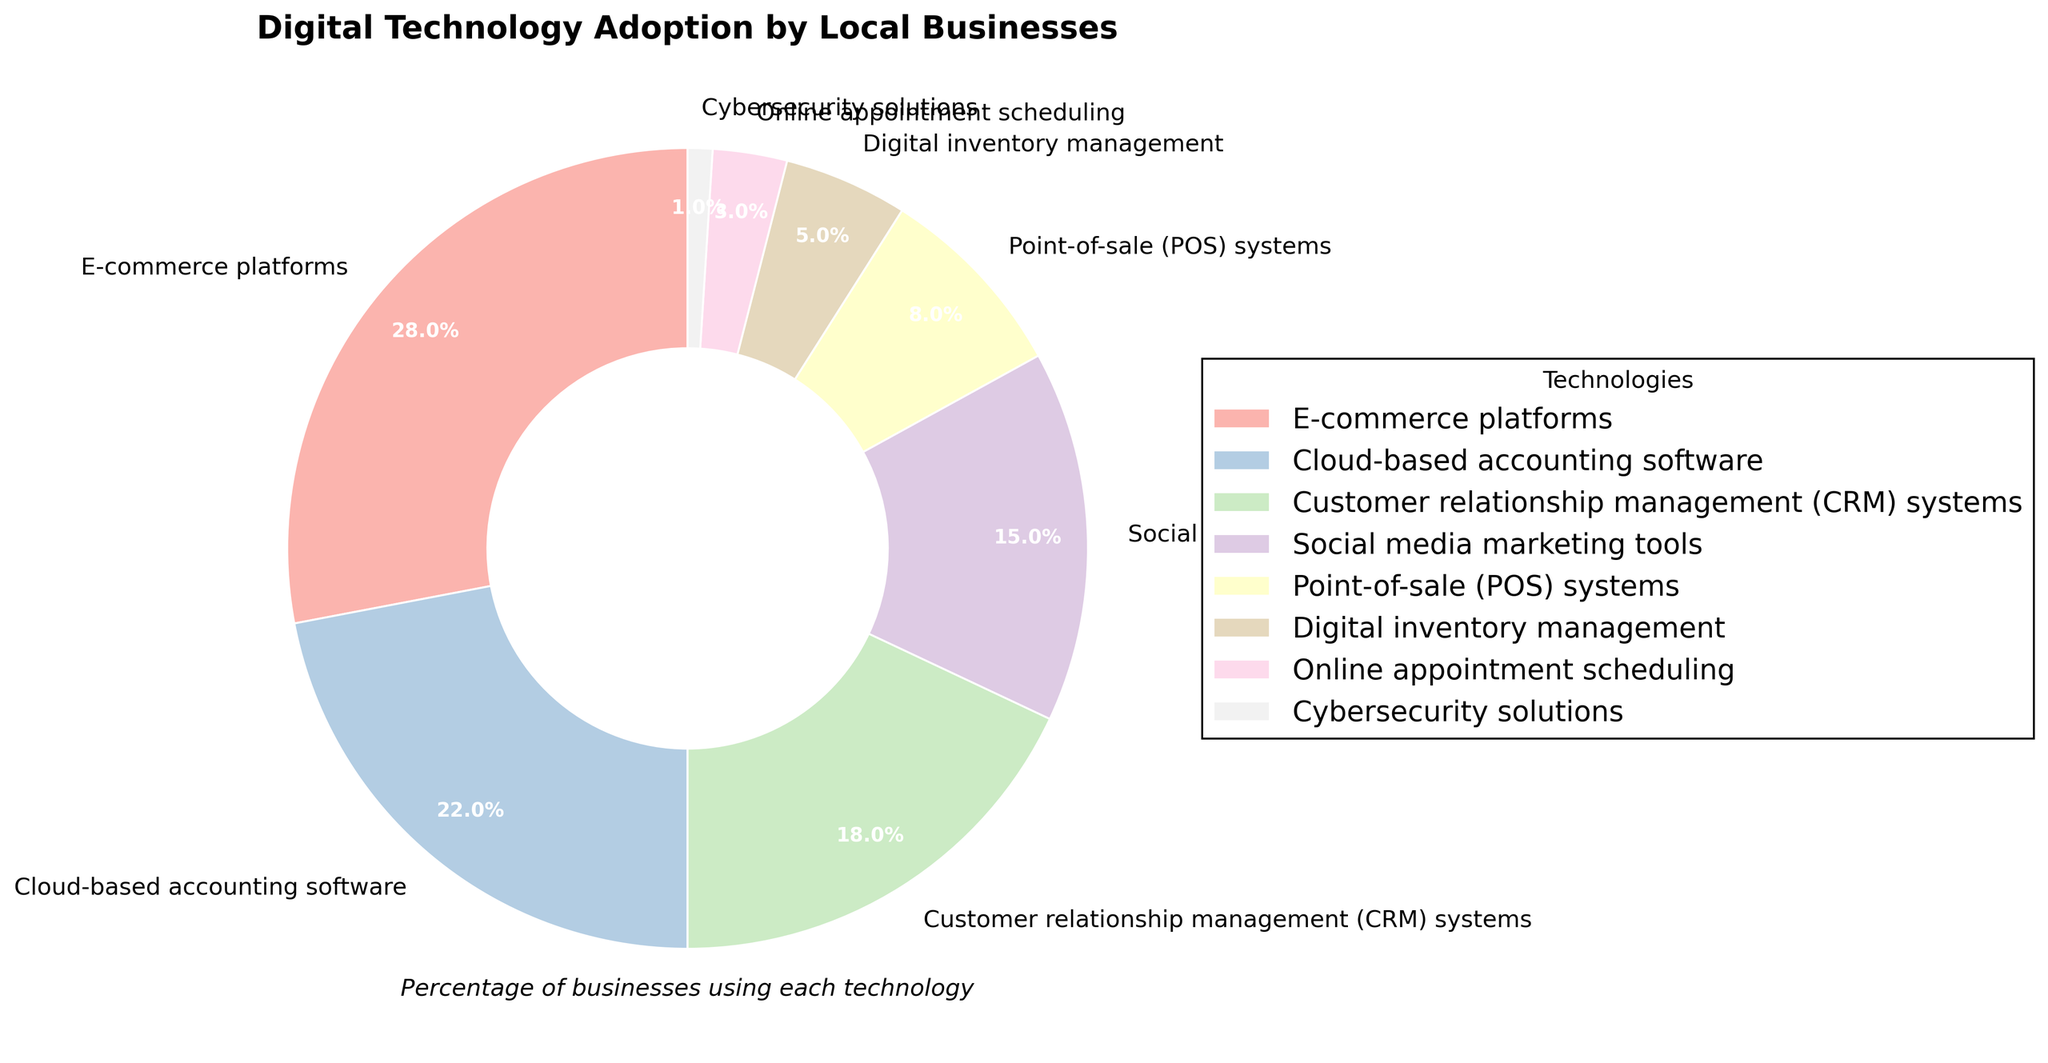What percentage of local businesses use CRM systems? Look at the section labeled "Customer relationship management (CRM) systems" in the pie chart. The percentage mentioned is 18%.
Answer: 18% What technology has the highest adoption rate among local businesses? Identify the segment of the pie chart with the largest area. The largest segment is labeled "E-commerce platforms," which accounts for 28%.
Answer: E-commerce platforms What is the combined percentage of businesses using Cloud-based accounting software and Point-of-sale (POS) systems? Find the segments labeled "Cloud-based accounting software" and "Point-of-sale (POS) systems" and add their percentages. Cloud-based accounting software is 22% and Point-of-sale (POS) systems is 8%. Combined, the total is 22% + 8% = 30%.
Answer: 30% How much more popular is Social media marketing tools compared to Cybersecurity solutions among local businesses? Look at the segments for "Social media marketing tools" and "Cybersecurity solutions." Social media marketing tools have a percentage of 15% and Cybersecurity solutions have 1%. The difference is 15% - 1% = 14%.
Answer: 14% Which is more commonly adopted: Digital inventory management or Online appointment scheduling? Review the percentages for "Digital inventory management" and "Online appointment scheduling." Digital inventory management holds 5%, whereas Online appointment scheduling is at 3%. Hence, Digital inventory management is more commonly adopted.
Answer: Digital inventory management What is the total percentage of businesses adopting technologies related to customer interaction (CRM systems and Social media marketing tools)? Add the percentages of "Customer relationship management (CRM) systems" and "Social media marketing tools." CRM systems account for 18% and Social media marketing tools account for 15%. Together, the total is 18% + 15% = 33%.
Answer: 33% Is the adoption rate of Customer relationship management (CRM) systems more than twice that of Digital inventory management? Compare the percentages for "Customer relationship management (CRM) systems" which is 18%, and "Digital inventory management," which is 5%. Check if 18% is more than twice of 5% (10%). As 18% is greater than 10%, the answer is yes.
Answer: Yes Which technology has the smallest adoption percentage among local businesses? Look at all segments and find the one with the smallest area. The smallest segment is labeled "Cybersecurity solutions," with 1%.
Answer: Cybersecurity solutions 